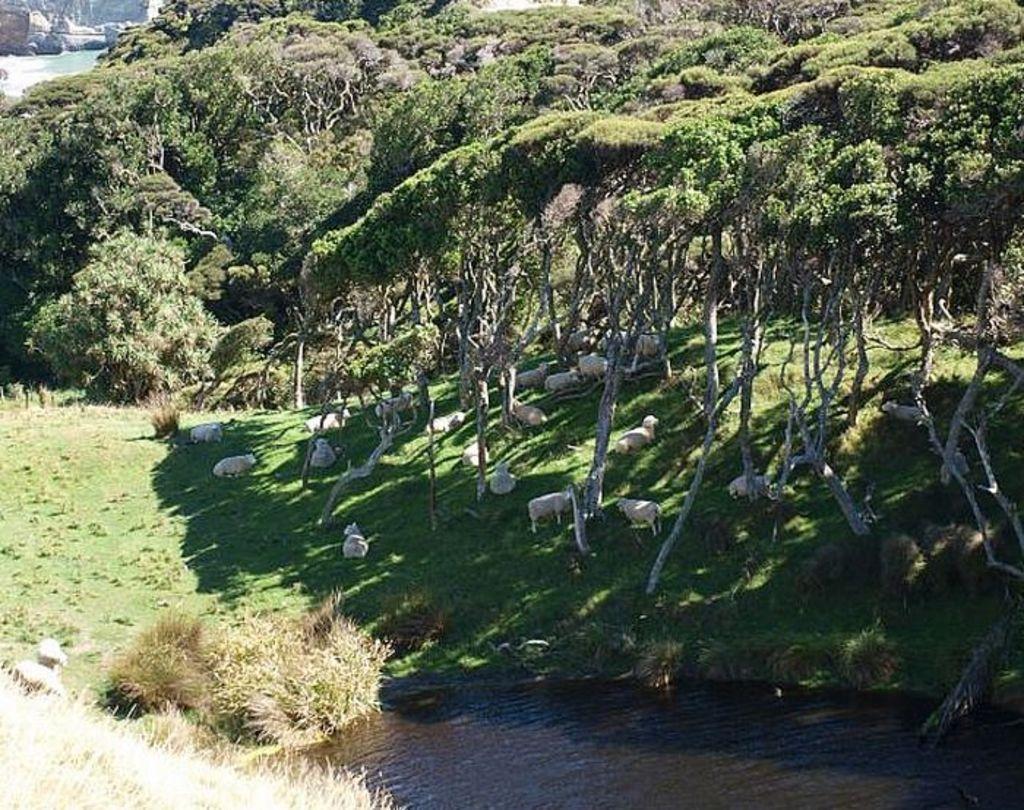Can you describe this image briefly? In this picture I can observe some trees. There are sheep on the ground. I can observe a small pond on the bottom of the picture. 